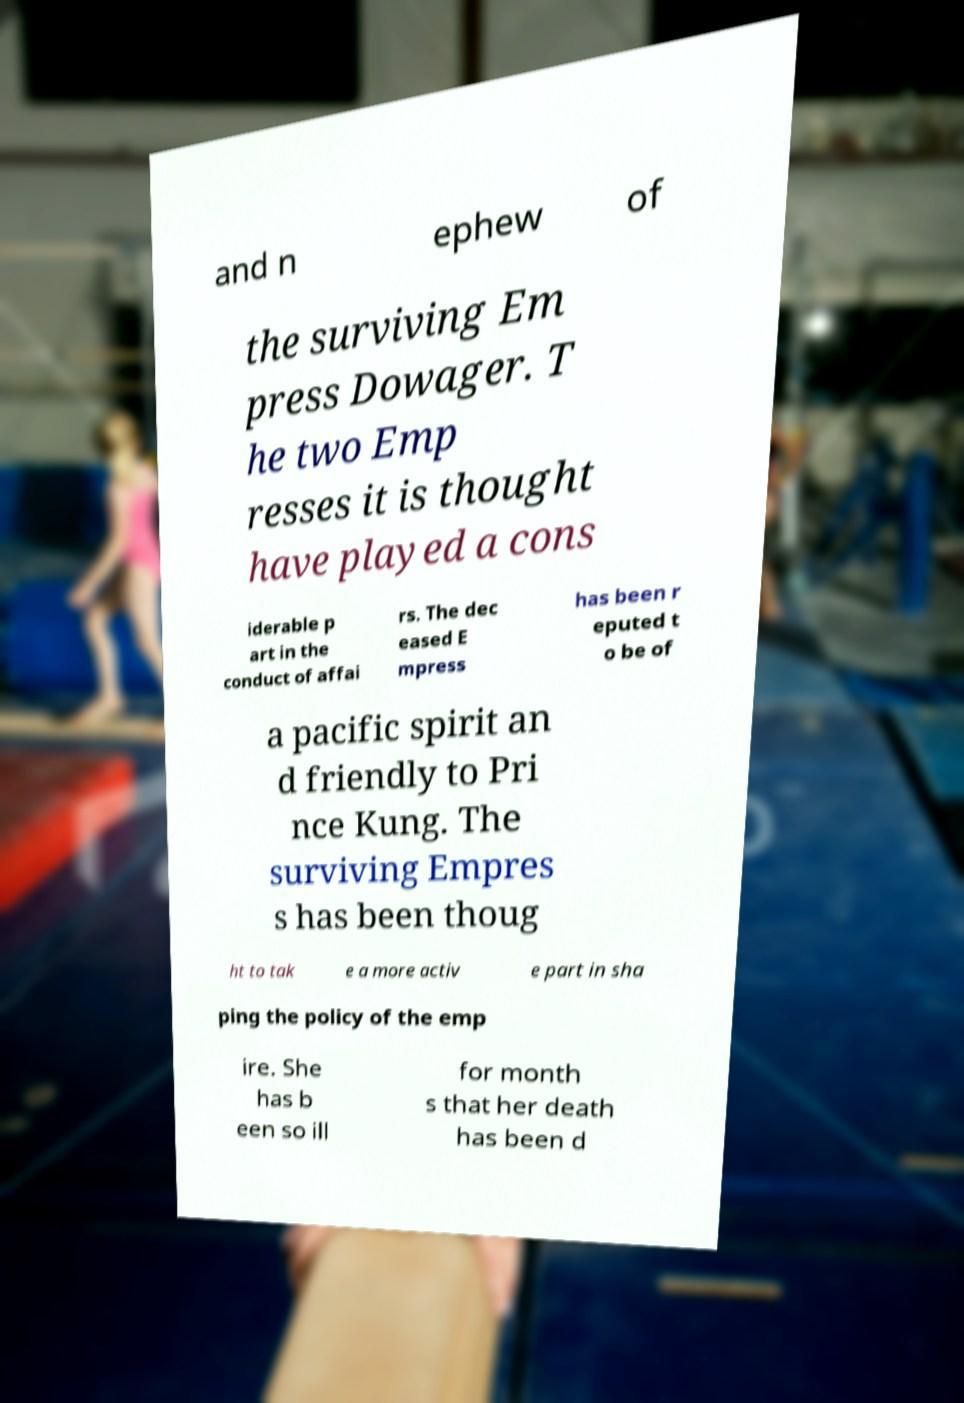I need the written content from this picture converted into text. Can you do that? and n ephew of the surviving Em press Dowager. T he two Emp resses it is thought have played a cons iderable p art in the conduct of affai rs. The dec eased E mpress has been r eputed t o be of a pacific spirit an d friendly to Pri nce Kung. The surviving Empres s has been thoug ht to tak e a more activ e part in sha ping the policy of the emp ire. She has b een so ill for month s that her death has been d 